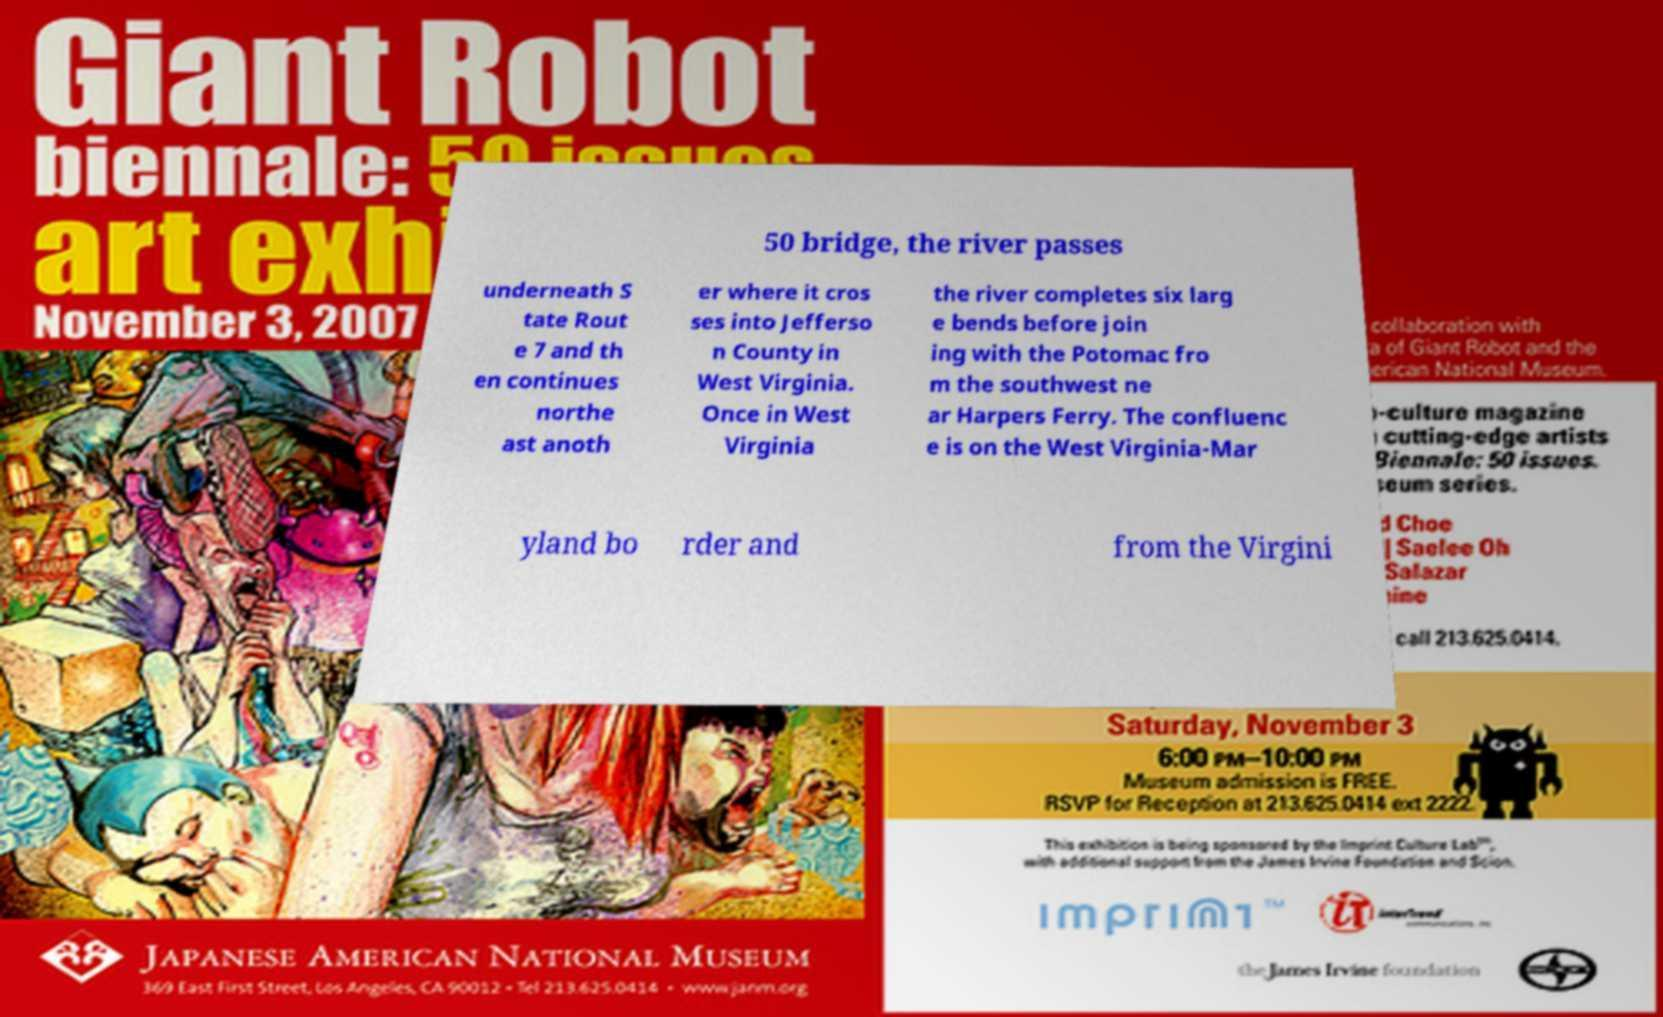Please read and relay the text visible in this image. What does it say? 50 bridge, the river passes underneath S tate Rout e 7 and th en continues northe ast anoth er where it cros ses into Jefferso n County in West Virginia. Once in West Virginia the river completes six larg e bends before join ing with the Potomac fro m the southwest ne ar Harpers Ferry. The confluenc e is on the West Virginia-Mar yland bo rder and from the Virgini 